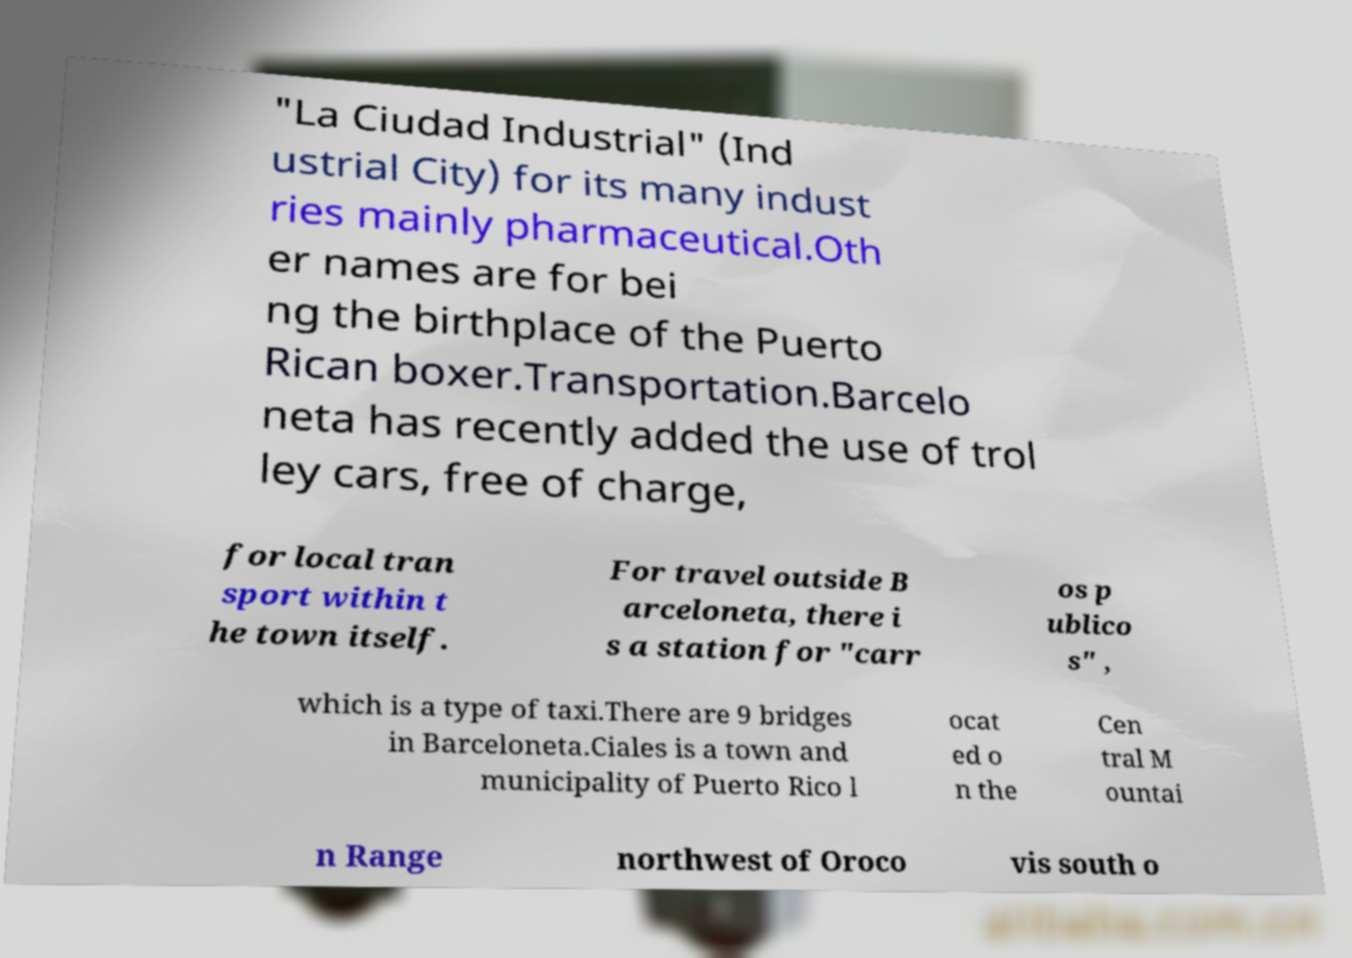For documentation purposes, I need the text within this image transcribed. Could you provide that? "La Ciudad Industrial" (Ind ustrial City) for its many indust ries mainly pharmaceutical.Oth er names are for bei ng the birthplace of the Puerto Rican boxer.Transportation.Barcelo neta has recently added the use of trol ley cars, free of charge, for local tran sport within t he town itself. For travel outside B arceloneta, there i s a station for "carr os p ublico s" , which is a type of taxi.There are 9 bridges in Barceloneta.Ciales is a town and municipality of Puerto Rico l ocat ed o n the Cen tral M ountai n Range northwest of Oroco vis south o 